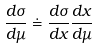Convert formula to latex. <formula><loc_0><loc_0><loc_500><loc_500>\frac { d \sigma } { d \mu } \doteq \frac { d \sigma } { d x } \frac { d x } { d \mu }</formula> 